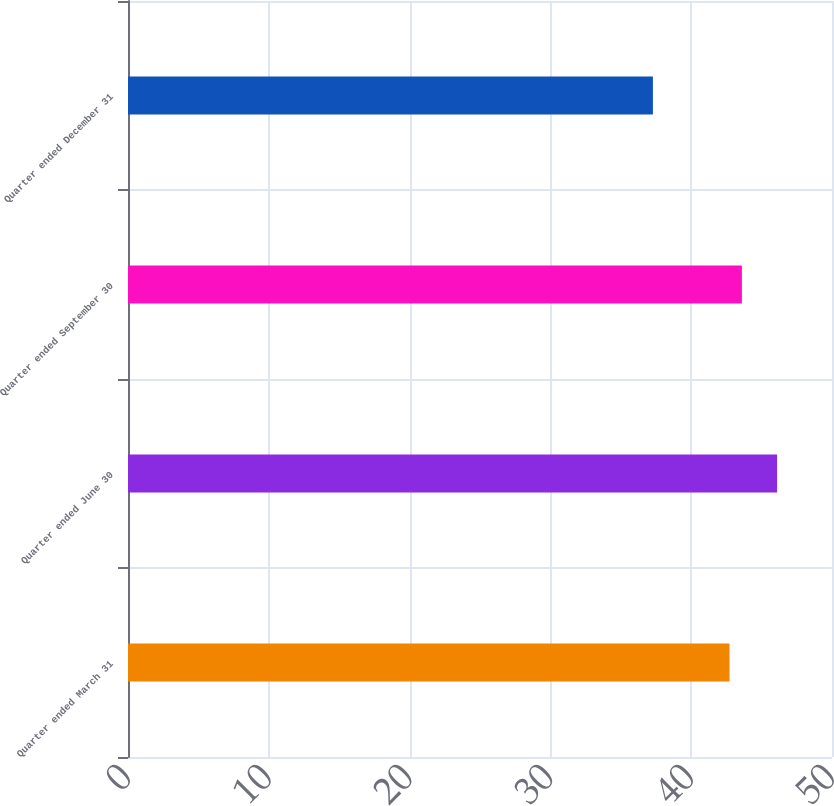Convert chart to OTSL. <chart><loc_0><loc_0><loc_500><loc_500><bar_chart><fcel>Quarter ended March 31<fcel>Quarter ended June 30<fcel>Quarter ended September 30<fcel>Quarter ended December 31<nl><fcel>42.72<fcel>46.1<fcel>43.6<fcel>37.28<nl></chart> 